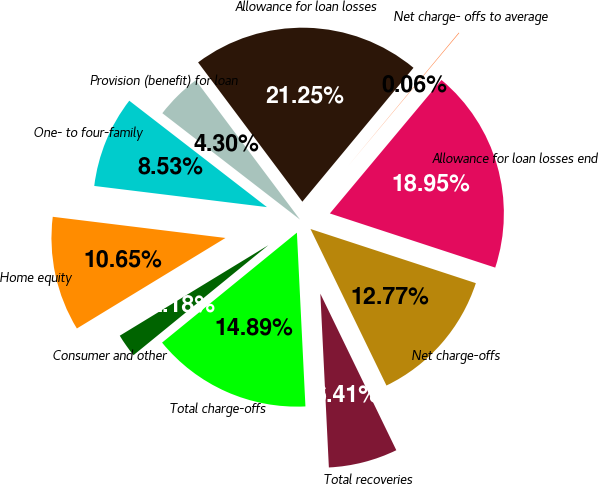<chart> <loc_0><loc_0><loc_500><loc_500><pie_chart><fcel>Allowance for loan losses<fcel>Provision (benefit) for loan<fcel>One- to four-family<fcel>Home equity<fcel>Consumer and other<fcel>Total charge-offs<fcel>Total recoveries<fcel>Net charge-offs<fcel>Allowance for loan losses end<fcel>Net charge- offs to average<nl><fcel>21.25%<fcel>4.3%<fcel>8.53%<fcel>10.65%<fcel>2.18%<fcel>14.89%<fcel>6.41%<fcel>12.77%<fcel>18.95%<fcel>0.06%<nl></chart> 